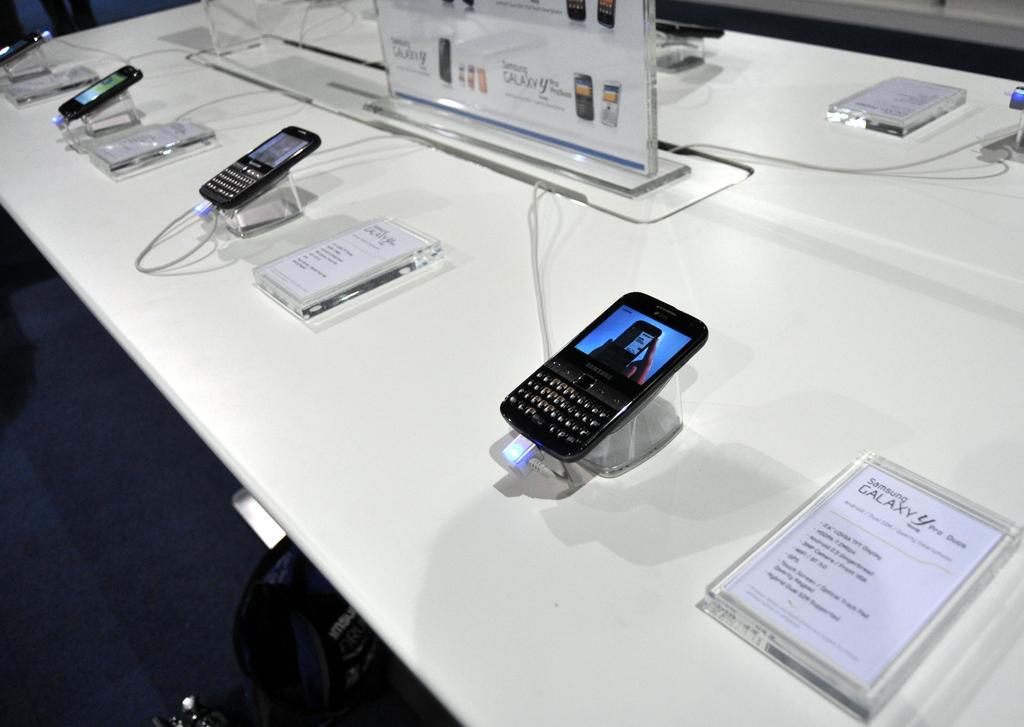What model of phone is being described on the right?
Provide a short and direct response. Galaxy y. Who makes the model of phone displayed?
Your answer should be very brief. Samsung. 